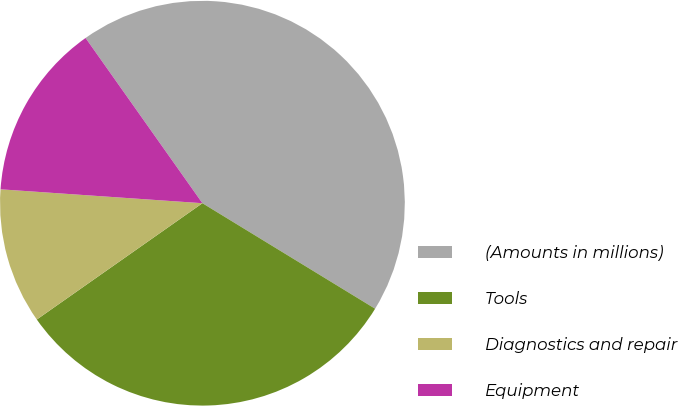<chart> <loc_0><loc_0><loc_500><loc_500><pie_chart><fcel>(Amounts in millions)<fcel>Tools<fcel>Diagnostics and repair<fcel>Equipment<nl><fcel>43.53%<fcel>31.53%<fcel>10.84%<fcel>14.11%<nl></chart> 